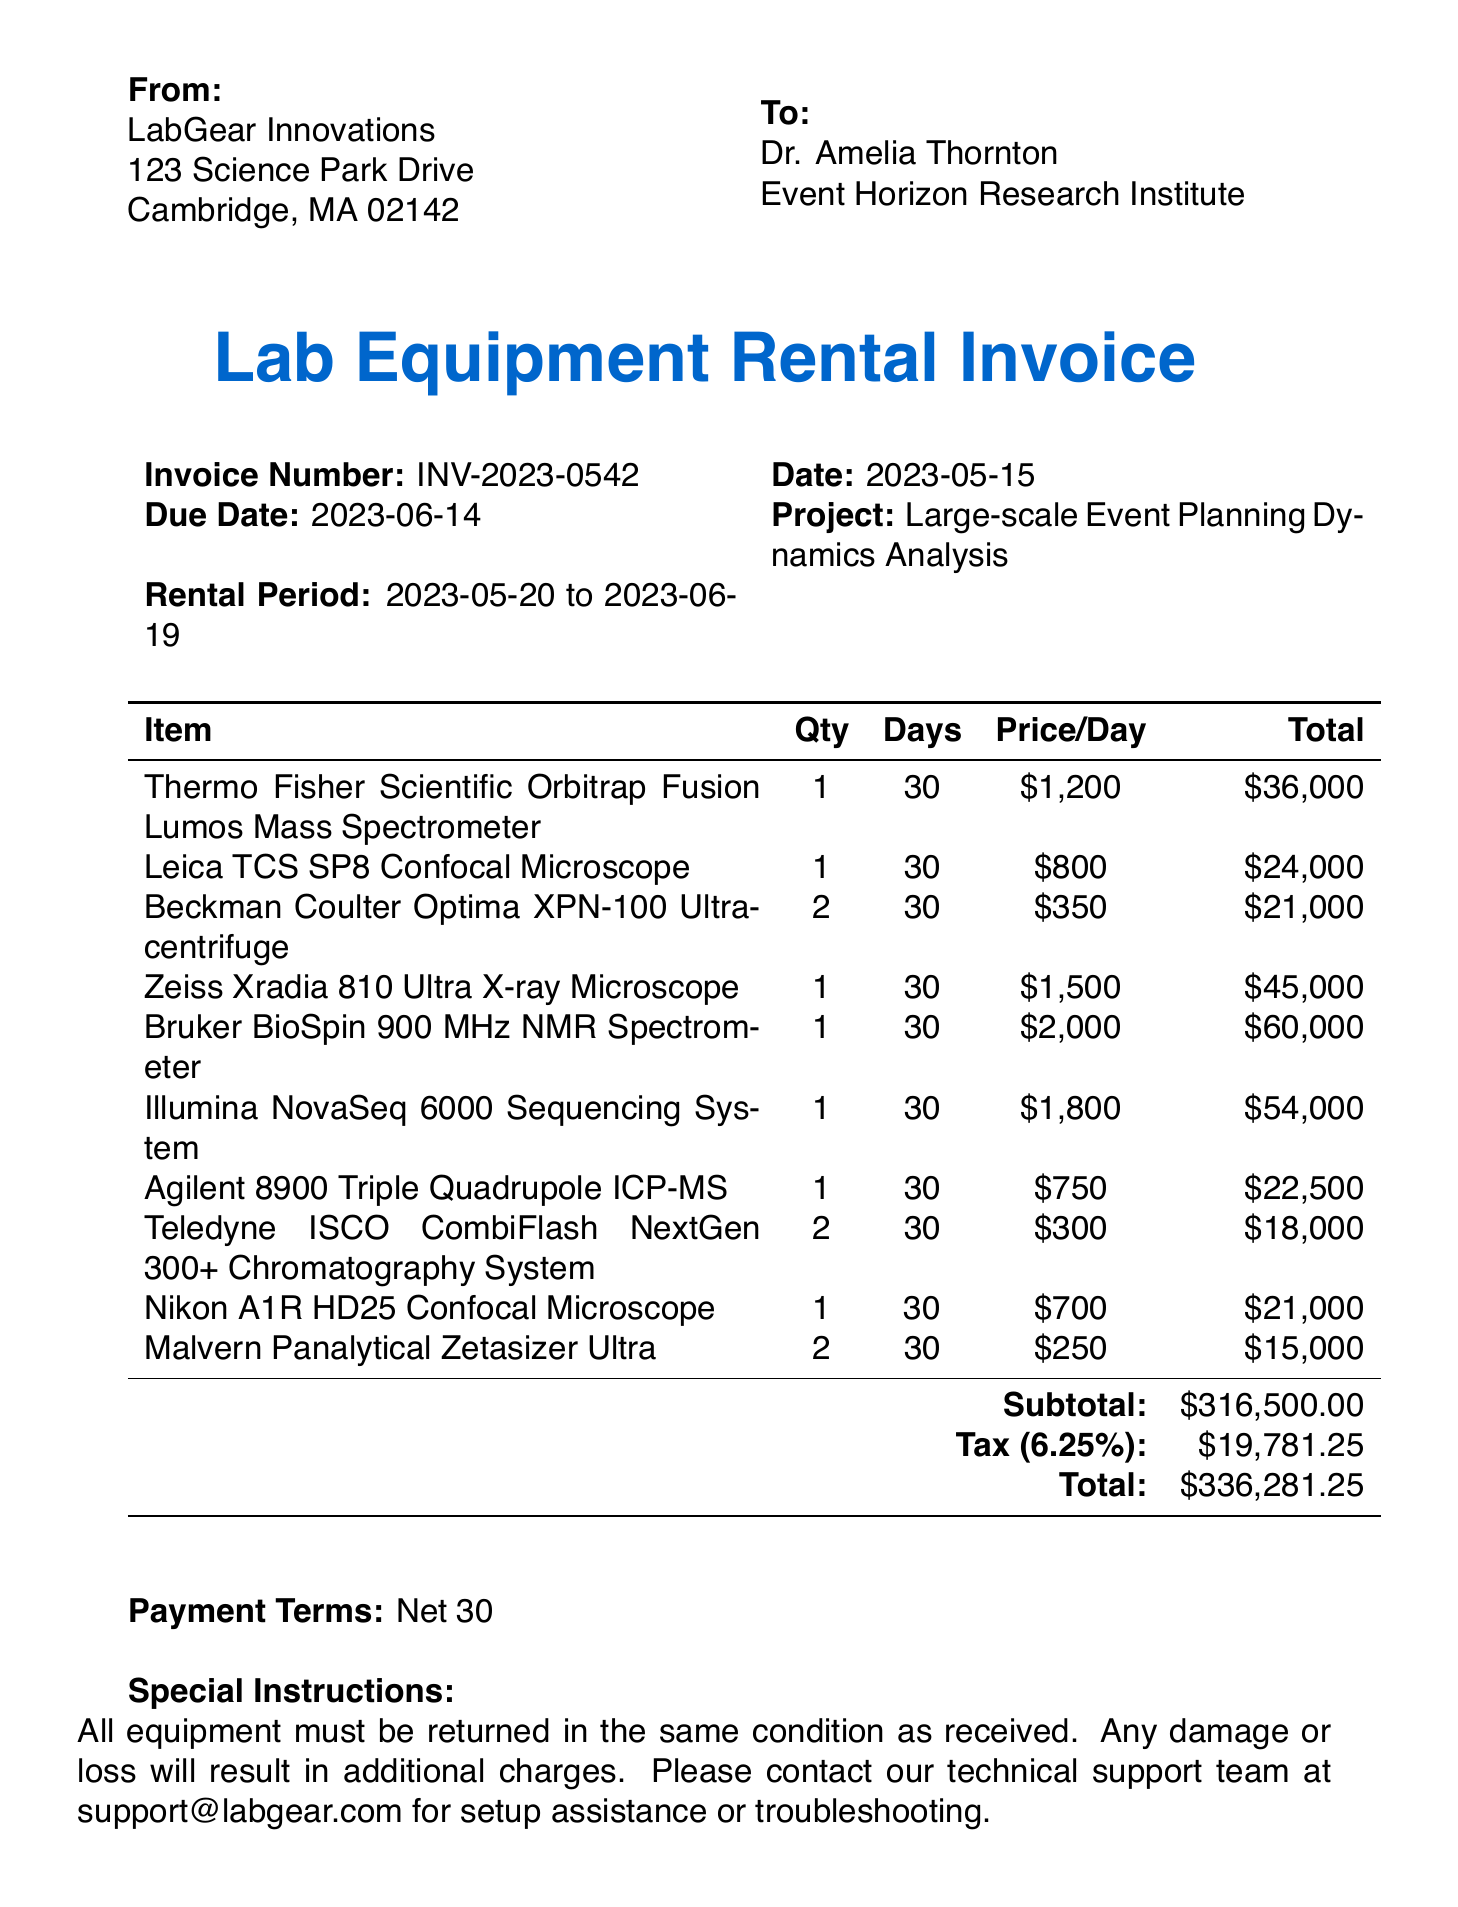what is the invoice number? The invoice number is clearly stated in the document, which is INV-2023-0542.
Answer: INV-2023-0542 who is the customer? The customer name is provided in the document as Dr. Amelia Thornton.
Answer: Dr. Amelia Thornton what is the total amount due? The total amount is calculated at the bottom of the invoice, which is $336,281.25.
Answer: $336,281.25 how many days is the rental period? The rental period is mentioned in the document, stating it is for 30 days.
Answer: 30 days what is the delivery method? The document specifies the delivery method, which is White Glove Delivery and Setup.
Answer: White Glove Delivery and Setup what is the tax rate stated in the invoice? The tax rate is provided in the invoice as 6.25%.
Answer: 6.25% how many pieces of the Beckman Coulter Optima XPN-100 Ultracentrifuge were rented? The document lists the quantity rented for this equipment, which is 2.
Answer: 2 what is the rental start date? The rental start date is specified in the document as May 20, 2023.
Answer: May 20, 2023 what insurance coverage is required? The document mentions an insurance requirement for the customer to provide proof of insurance covering up to $5,000,000.
Answer: $5,000,000 